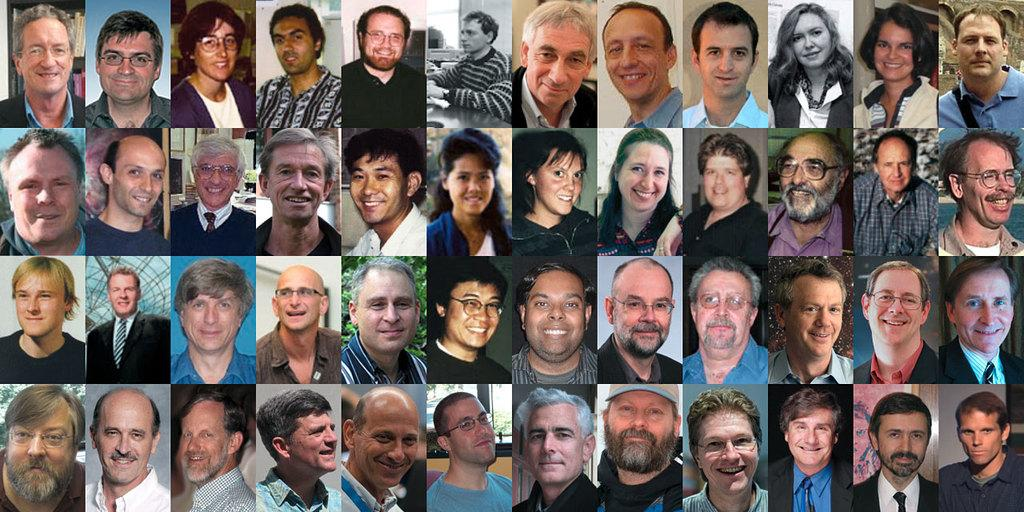What is the main subject of the image? The main subject of the image is multiple images of people. Can you describe the people in the images? Unfortunately, the provided facts do not include any information about the people in the images. Are there any other elements in the image besides the images of people? The provided facts do not mention any other elements in the image. What type of spy equipment can be seen in the image? There is no mention of spy equipment or any other objects in the image besides the images of people. 